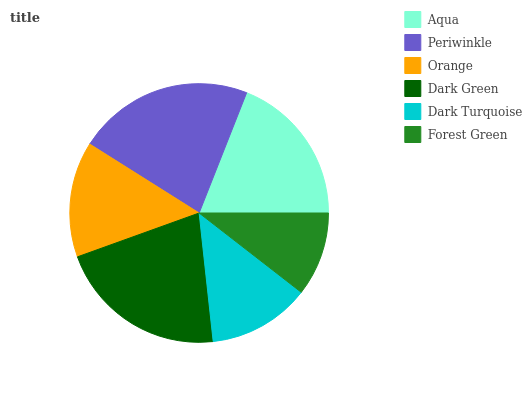Is Forest Green the minimum?
Answer yes or no. Yes. Is Periwinkle the maximum?
Answer yes or no. Yes. Is Orange the minimum?
Answer yes or no. No. Is Orange the maximum?
Answer yes or no. No. Is Periwinkle greater than Orange?
Answer yes or no. Yes. Is Orange less than Periwinkle?
Answer yes or no. Yes. Is Orange greater than Periwinkle?
Answer yes or no. No. Is Periwinkle less than Orange?
Answer yes or no. No. Is Aqua the high median?
Answer yes or no. Yes. Is Orange the low median?
Answer yes or no. Yes. Is Periwinkle the high median?
Answer yes or no. No. Is Dark Turquoise the low median?
Answer yes or no. No. 